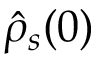Convert formula to latex. <formula><loc_0><loc_0><loc_500><loc_500>\hat { \rho } _ { s } ( 0 )</formula> 